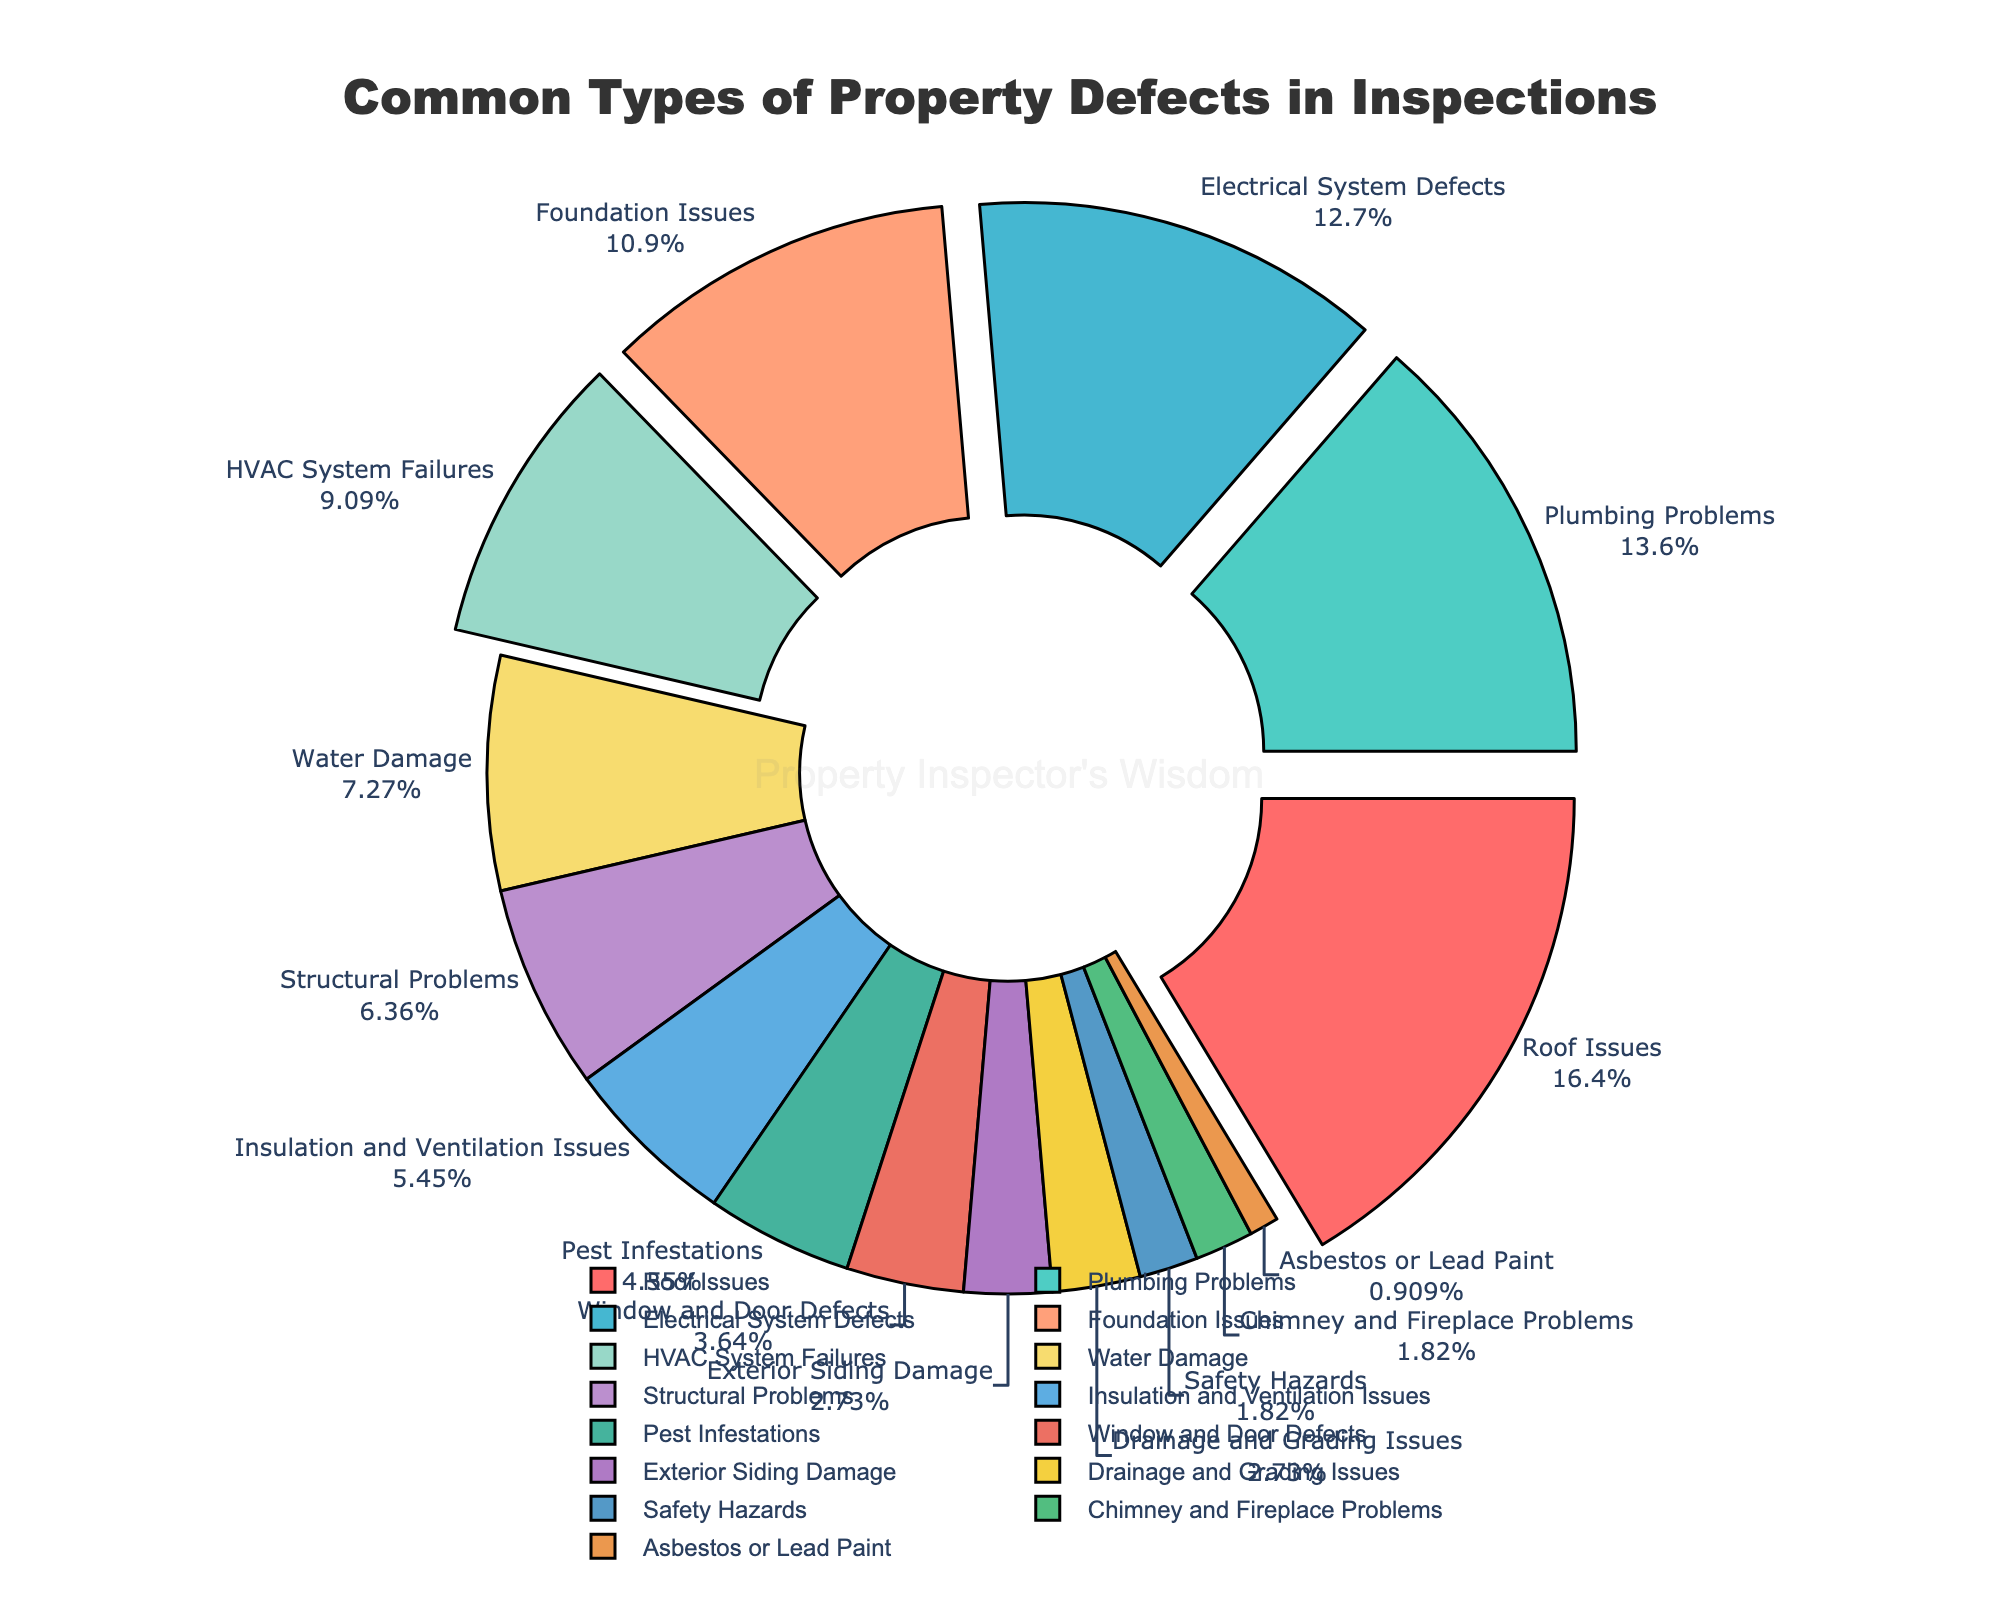What are the top three most common property defects found during inspections? Refer to the pie chart and identify the defects with the highest percentages. The top three are Roof Issues (18%), Plumbing Problems (15%), and Electrical System Defects (14%).
Answer: Roof Issues, Plumbing Problems, Electrical System Defects How much more common are Foundation Issues compared to Structural Problems? Find the percentage for both Foundation Issues (12%) and Structural Problems (7%), then subtract the latter from the former. 12% - 7% = 5%, so Foundation Issues are 5% more common.
Answer: 5% What is the combined percentage of HVAC System Failures, Water Damage, and Insulation and Ventilation Issues? Sum up the percentages of HVAC System Failures (10%), Water Damage (8%), and Insulation and Ventilation Issues (6%). 10% + 8% + 6% = 24%.
Answer: 24% Which property defect has a smaller percentage, Pest Infestations or Window and Door Defects? Compare the two percentages: Pest Infestations (5%) and Window and Door Defects (4%). Window and Door Defects have a smaller percentage.
Answer: Window and Door Defects What is the total percentage of defects related to structural integrity (Safely Hazards, Structural Problems, Foundation Issues)? Sum up the percentages for Safety Hazards (2%), Structural Problems (7%), and Foundation Issues (12%). 2% + 7% + 12% = 21%.
Answer: 21% Which defect categories are visually highlighted with an offset from the pie chart? Visually check which categories are "pulled" out from the main pie, indicating they are highlighted. These are the top five categories: Roof Issues, Plumbing Problems, Electrical System Defects, Foundation Issues, and HVAC System Failures.
Answer: Roof Issues, Plumbing Problems, Electrical System Defects, Foundation Issues, HVAC System Failures What is the percentage difference between Roof Issues and Asbestos or Lead Paint? Subtract the percentage of Asbestos or Lead Paint (1%) from that of Roof Issues (18%). 18% - 1% = 17%.
Answer: 17% Among Defects related to interior systems (Plumbing Problems, Electrical System Defects, HVAC System Failures), which one has the lowest percentage? Compare the percentages of Plumbing Problems (15%), Electrical System Defects (14%), and HVAC System Failures (10%). HVAC System Failures has the lowest percentage.
Answer: HVAC System Failures What fraction of the pie chart is covered by defects with less than 5% each? Identify the defects that are less than 5% (Window and Door Defects, Exterior Siding Damage, Drainage and Grading Issues, Safety Hazards, Chimney and Fireplace Problems, Asbestos or Lead Paint), sum their percentages (4% + 3% + 3% + 2% + 2% + 1% = 15%), and calculate the fraction. 15% of 100% is 15/100 or 3/20.
Answer: 15% or 3/20 